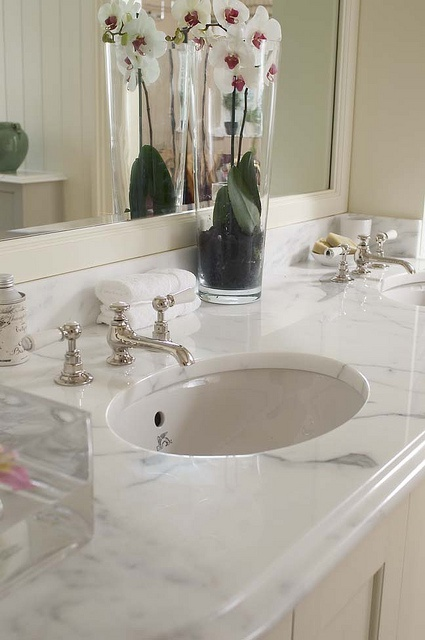Describe the objects in this image and their specific colors. I can see sink in darkgray, gray, and lightgray tones, vase in darkgray, black, lightgray, and gray tones, and sink in darkgray and lightgray tones in this image. 